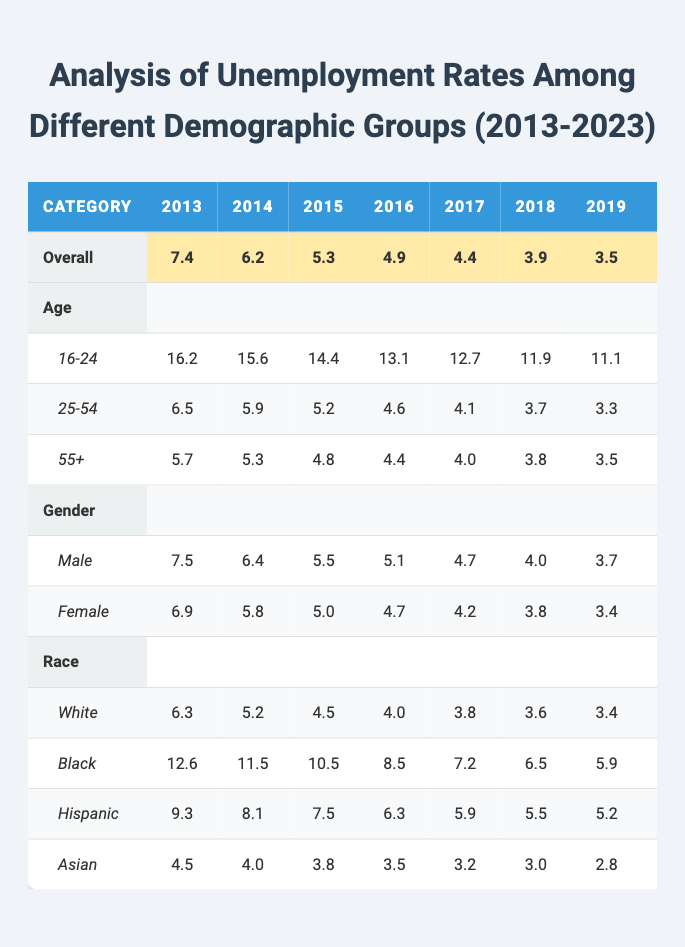What was the overall unemployment rate in 2020? The overall unemployment rate for 2020 is listed in the table as 8.1.
Answer: 8.1 Which demographic group had the highest unemployment rate in 2013? In 2013, the demographic group with the highest unemployment rate was the 16-24 age group at 16.2.
Answer: 16-24 age group What is the average unemployment rate for the Hispanic demographic from 2013 to 2023? To find the average Hispanic unemployment rate, add the values for each year: (9.3 + 8.1 + 7.5 + 6.3 + 5.9 + 5.5 + 5.2 + 10.5 + 8.0 + 5.2 + 5.0) = 71.5. There are 11 data points, so the average is 71.5 / 11 = 6.5.
Answer: 6.5 Did the unemployment rate for the 55+ age group decrease from 2013 to 2023? Yes, the unemployment rate for the 55+ age group in 2013 was 5.7 and decreased to 3.1 in 2023, indicating a decrease.
Answer: Yes What was the difference in unemployment rates between Black and White demographics in 2021? In 2021, the unemployment rate for Black individuals was 9.0, and for White individuals, it was 5.8. The difference is calculated as 9.0 - 5.8 = 3.2.
Answer: 3.2 